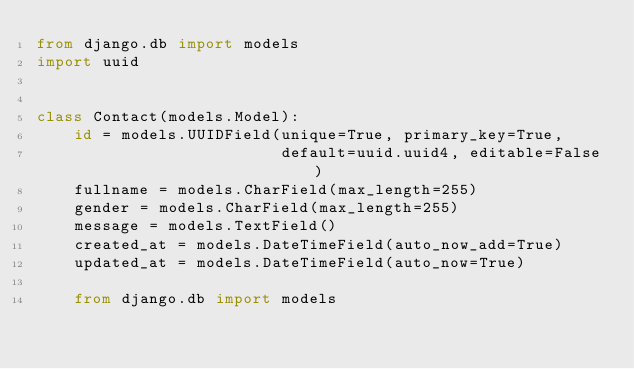Convert code to text. <code><loc_0><loc_0><loc_500><loc_500><_Python_>from django.db import models
import uuid


class Contact(models.Model):
    id = models.UUIDField(unique=True, primary_key=True,
                          default=uuid.uuid4, editable=False)
    fullname = models.CharField(max_length=255)
    gender = models.CharField(max_length=255)
    message = models.TextField()
    created_at = models.DateTimeField(auto_now_add=True)
    updated_at = models.DateTimeField(auto_now=True)

    from django.db import models
</code> 